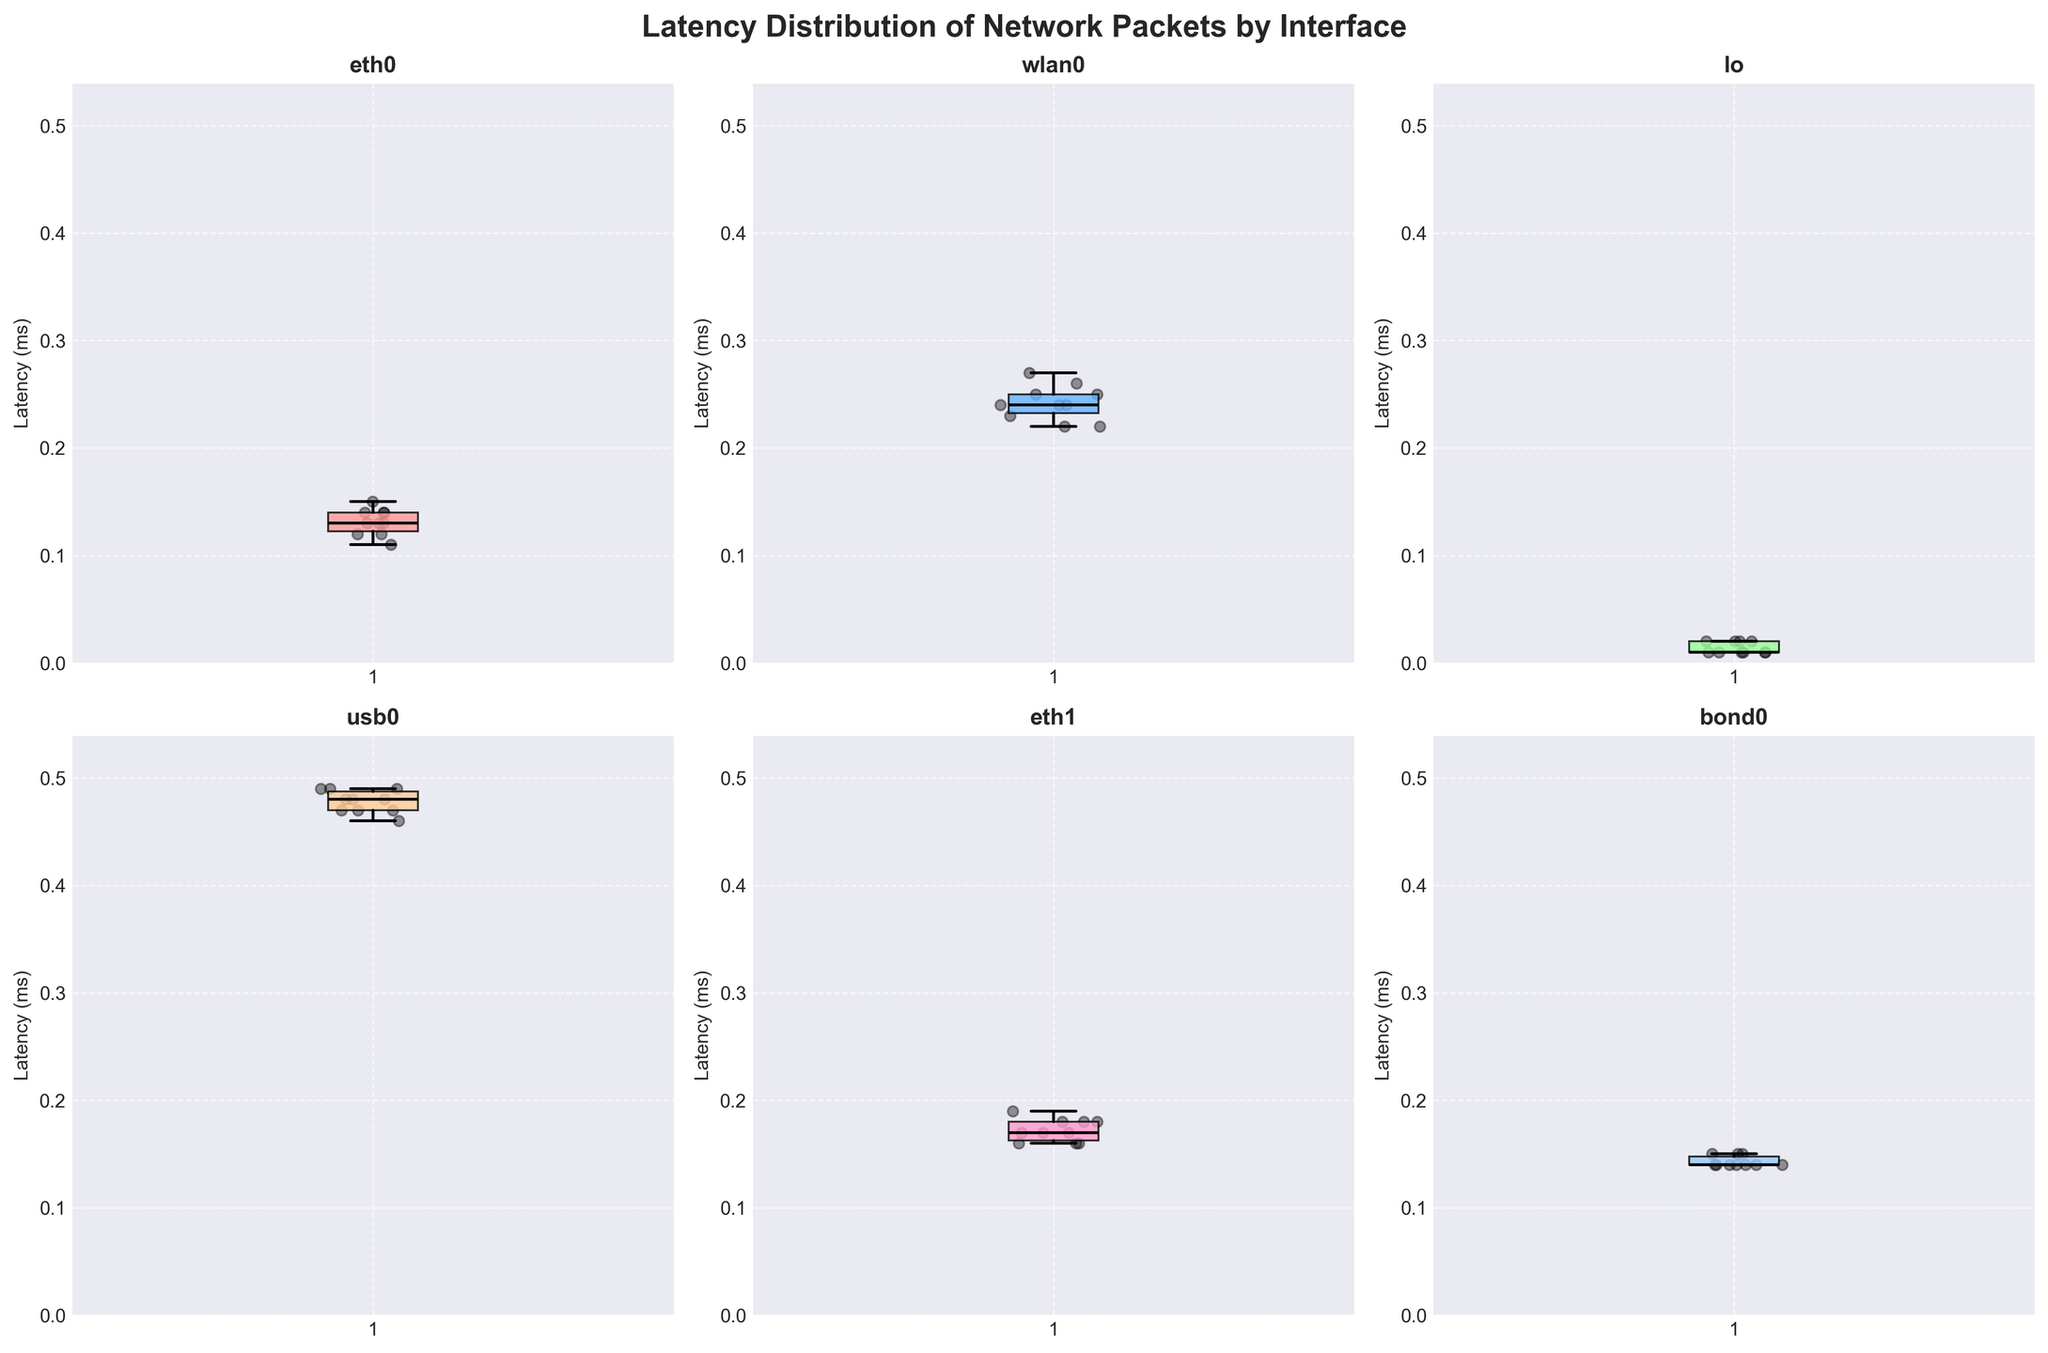How many network interfaces are represented in the figure? The figure contains subplots for each network interface, and by counting the titles in each subplot, we can determine that there are six network interfaces.
Answer: Six What is the title of the figure? The title is displayed at the top of the figure in a larger and bolded font. It reads "Latency Distribution of Network Packets by Interface."
Answer: Latency Distribution of Network Packets by Interface Which network interface has the highest median latency? By observing the median lines (dark horizontal lines) inside the boxes of each subplot, we can see that the interface `usb0` has the highest median latency.
Answer: usb0 What is the median latency of the interface `lo`? The median latency is depicted as the dark horizontal line within the box in the `lo` subplot. The line is at 0.01 ms.
Answer: 0.01 ms Compare the range (difference between maximum and minimum values) of latencies for `eth0` and `eth1`. Which has a bigger range? For `eth0`, the range of latencies is between approximately 0.11 ms and 0.15 ms, giving a range of 0.04 ms. For `eth1`, the range is between approximately 0.16 ms and 0.19 ms, giving a range of 0.03 ms. So, `eth0` has a bigger range.
Answer: eth0 Which interface's subplot shows the smallest spread (difference between the first and third quartile) of latency values? By looking at the width of the boxes in each subplot, each box represents the interquartile range (IQR). The interface `lo` has the smallest box, indicating the smallest spread.
Answer: lo What is the approximate maximum latency value for the interface `wlan0`? In the `wlan0` subplot, the upper whisker (top line) indicates the maximum latency value, which is approximately 0.27 ms.
Answer: 0.27 ms Which network interface has the most consistent latency values (smallest interquartile range and overall spread)? The consistency of latency values can be inferred from the smallest spread and smallest interquartile range. The interface `lo` shows the least variability, evidenced by its narrow interquartile range and spread.
Answer: lo Can you identify any outliers in the latency distributions? Outliers in box plots are typically shown as individual points outside the whiskers. None of the subplots display such outliers, indicating no extreme values in this data set.
Answer: No 